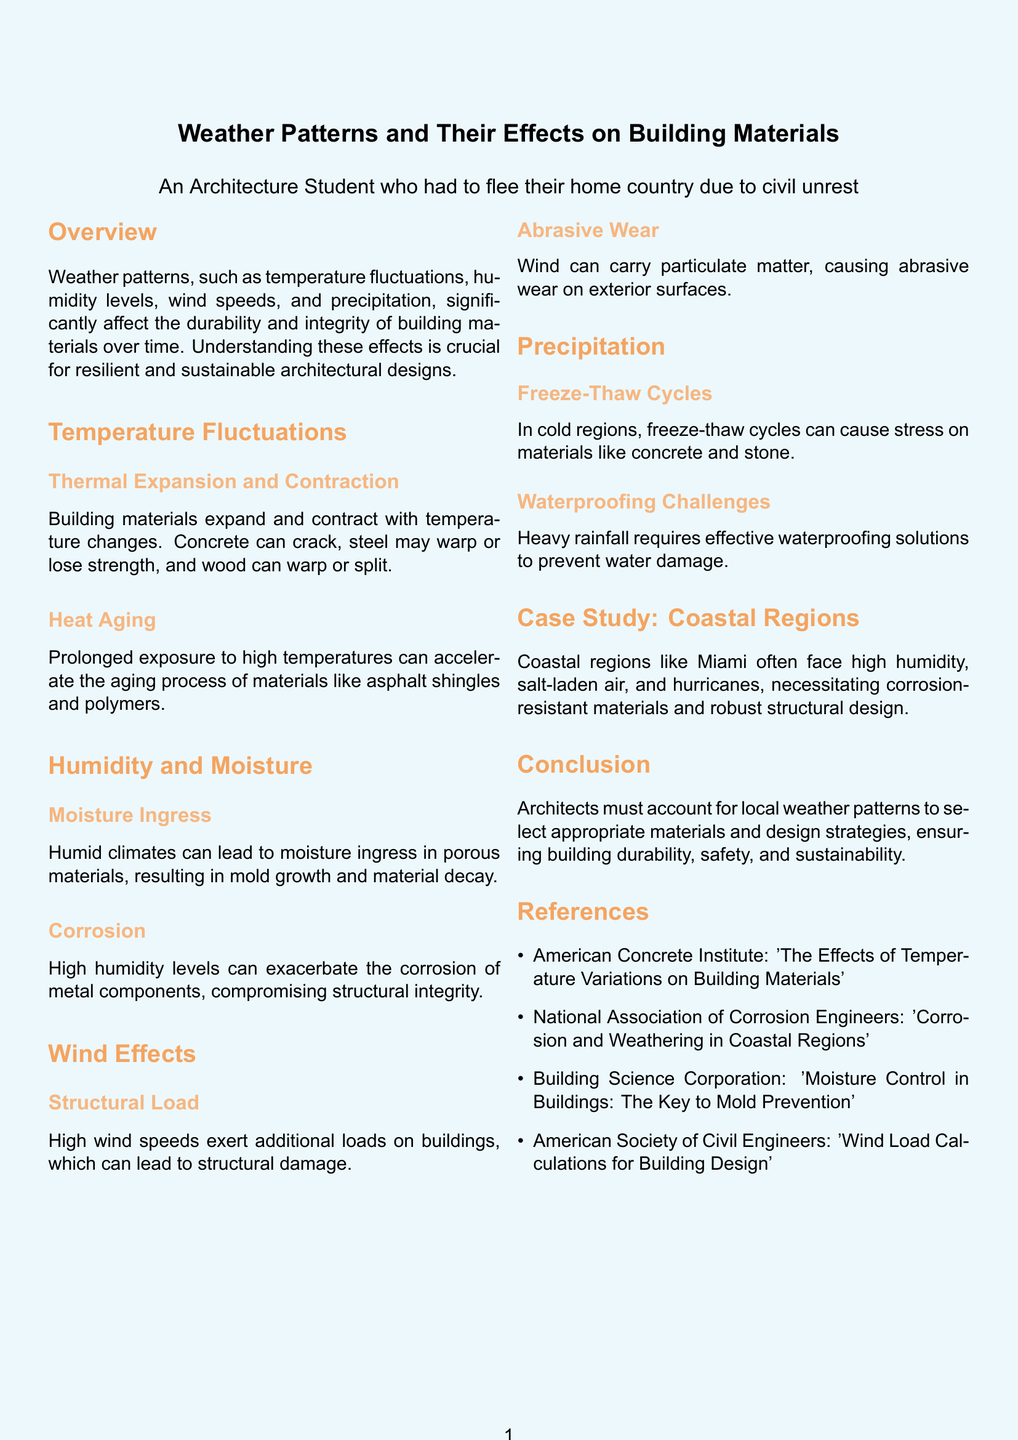What are the main weather patterns affecting building materials? The main weather patterns affecting building materials include temperature fluctuations, humidity levels, wind speeds, and precipitation.
Answer: Temperature fluctuations, humidity levels, wind speeds, precipitation What can cause concrete to crack? Concrete can crack due to thermal expansion and contraction with temperature changes.
Answer: Thermal expansion and contraction What can high humidity levels exacerbate? High humidity levels can exacerbate the corrosion of metal components.
Answer: Corrosion of metal components In which regions do freeze-thaw cycles cause stress on materials? Freeze-thaw cycles cause stress on materials like concrete and stone in cold regions.
Answer: Cold regions What does the case study focus on? The case study focuses on coastal regions, such as Miami.
Answer: Coastal regions What is required to prevent water damage during heavy rainfall? Effective waterproofing solutions are required to prevent water damage during heavy rainfall.
Answer: Effective waterproofing solutions What is a consequence of high wind speeds on buildings? High wind speeds exert additional loads on buildings, which can lead to structural damage.
Answer: Structural damage What deterioration process is accelerated by prolonged exposure to high temperatures? Prolonged exposure to high temperatures accelerates the aging process of materials like asphalt shingles and polymers.
Answer: Aging process Which association published information on corrosion and weathering in coastal regions? The National Association of Corrosion Engineers published information on corrosion and weathering in coastal regions.
Answer: National Association of Corrosion Engineers 